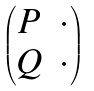Convert formula to latex. <formula><loc_0><loc_0><loc_500><loc_500>\begin{pmatrix} P & \cdot \\ Q & \cdot \end{pmatrix}</formula> 